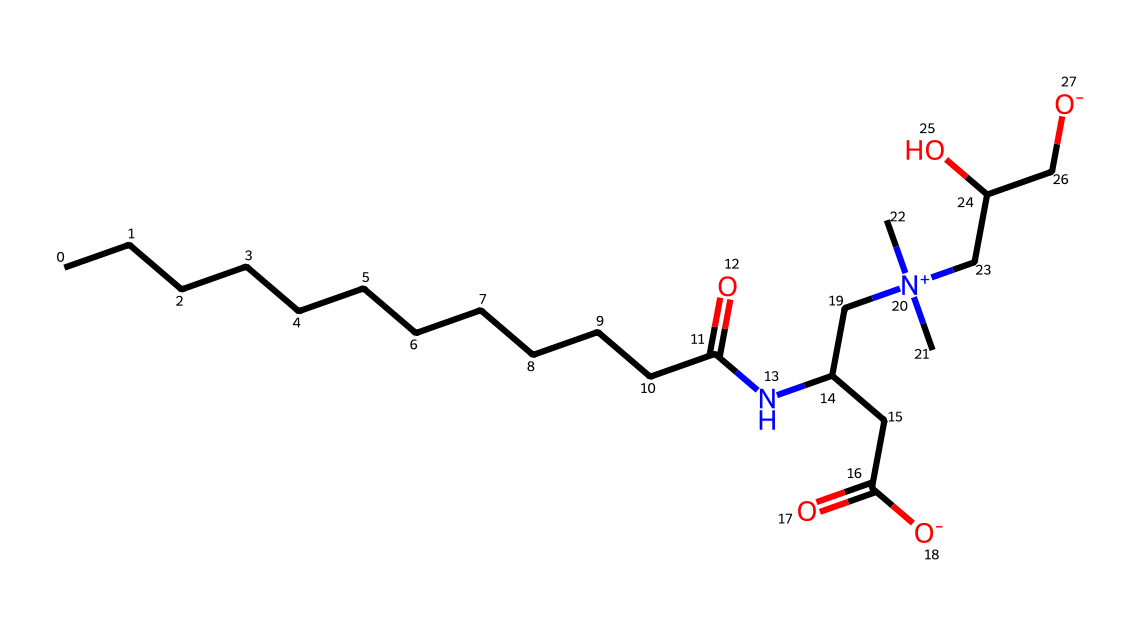What is the total number of carbon atoms in cocamidopropyl betaine? By examining the SMILES representation, we count the number of 'C' characters. There are 14 carbon atoms present in total.
Answer: 14 How many nitrogen atoms are present in the chemical structure? In the SMILES, we look for the occurrences of 'N'. There is one nitrogen atom in the structure of cocamidopropyl betaine.
Answer: 1 What is the functional group that classifies this molecule as a surfactant? The presence of a quaternary ammonium group (indicated by [N+](C)(C)...) is characteristic of surfactants, as it allows the molecule to have both hydrophilic and lipophilic properties, which aids in lowering surface tension.
Answer: quaternary ammonium What type of bond connects the carbon chain to the amine group in cocamidopropyl betaine? The connection between the carbon chain and the amine group involves a carbon-nitrogen (C-N) single bond as indicated by the structure, which includes an amide linkage.
Answer: single bond What is the charge on the nitrogen atom in cocamidopropyl betaine? The nitrogen atom appears with a positive charge indicated by [N+], which reveals that the nitrogen is positively charged due to the attachment of three carbon substituents.
Answer: positive How does the presence of carboxylate groups affect the solubility of cocamidopropyl betaine? The carboxylate group presents a hydrophilic region, allowing the molecule to interact favorably with water, thereby enhancing its solubility in aqueous solutions which is crucial for a surfactant function.
Answer: increases solubility 